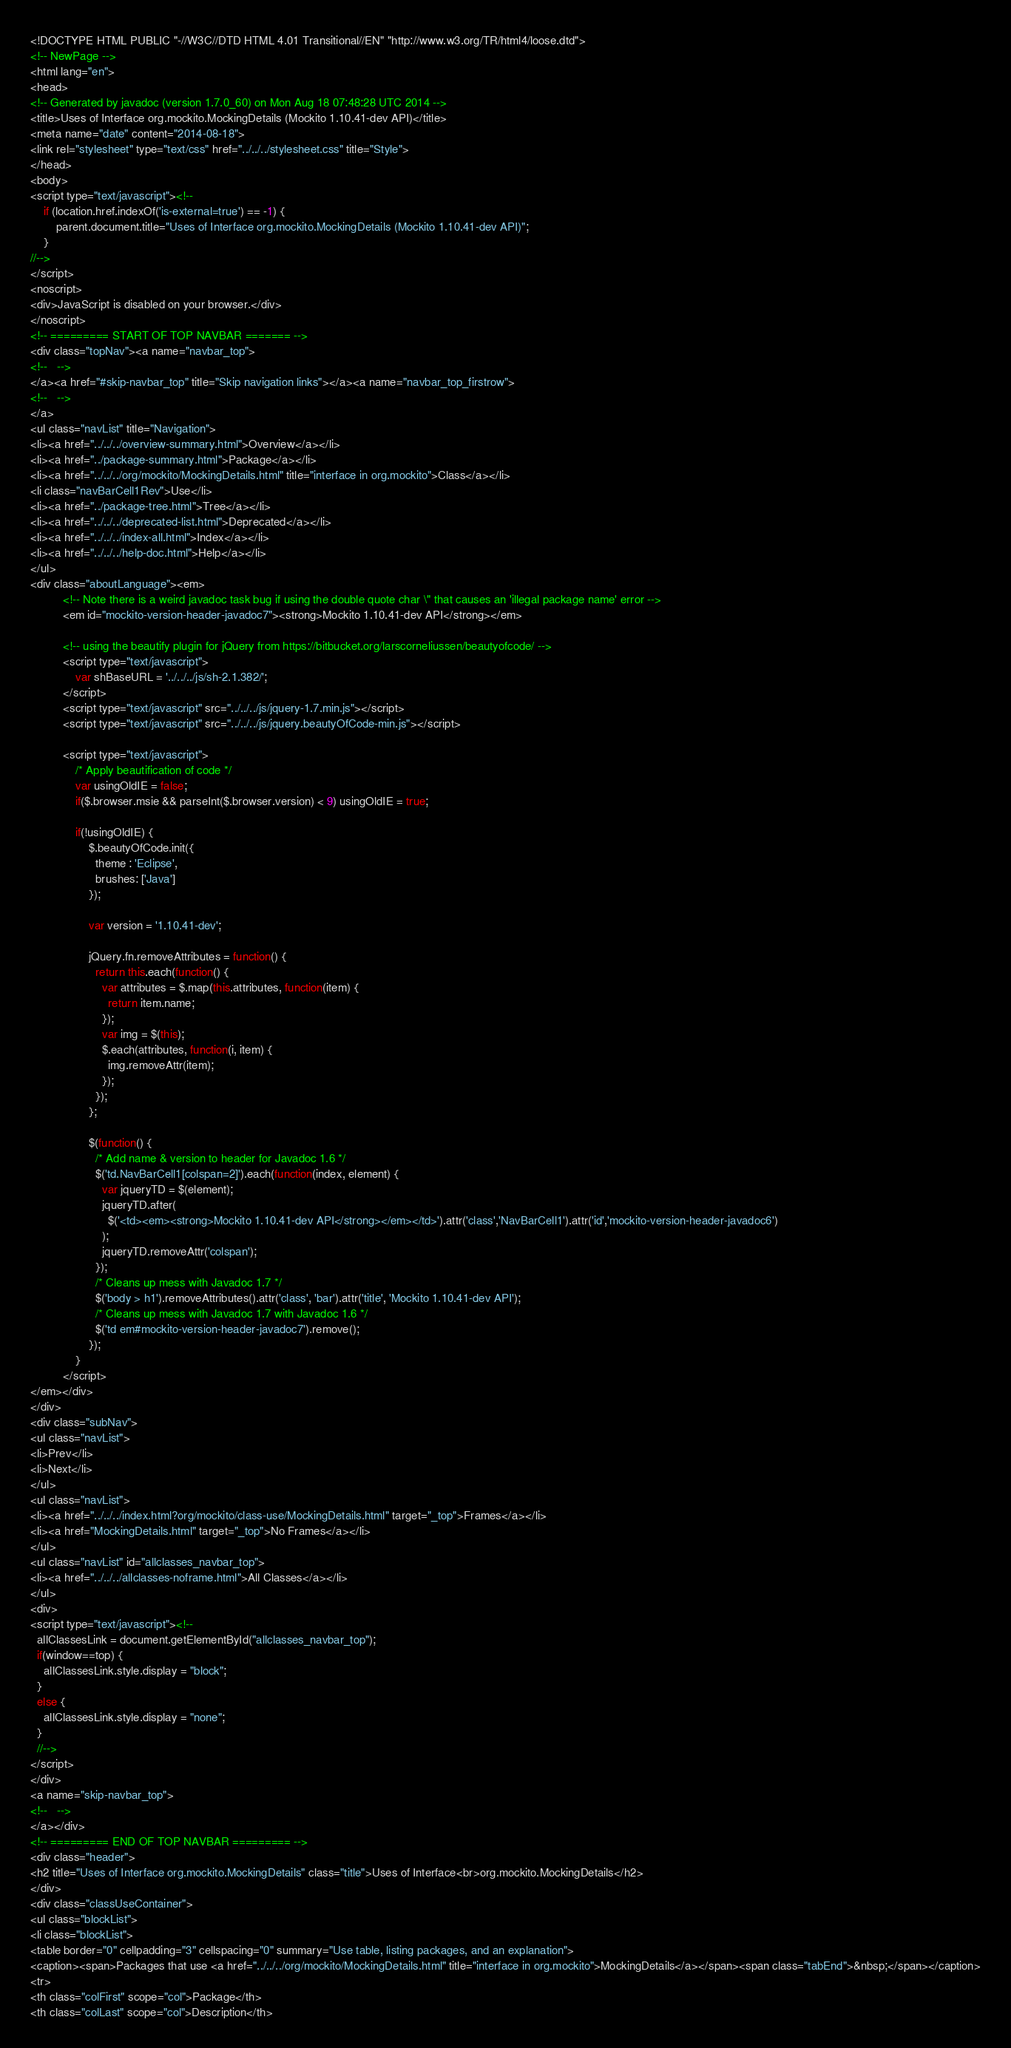Convert code to text. <code><loc_0><loc_0><loc_500><loc_500><_HTML_><!DOCTYPE HTML PUBLIC "-//W3C//DTD HTML 4.01 Transitional//EN" "http://www.w3.org/TR/html4/loose.dtd">
<!-- NewPage -->
<html lang="en">
<head>
<!-- Generated by javadoc (version 1.7.0_60) on Mon Aug 18 07:48:28 UTC 2014 -->
<title>Uses of Interface org.mockito.MockingDetails (Mockito 1.10.41-dev API)</title>
<meta name="date" content="2014-08-18">
<link rel="stylesheet" type="text/css" href="../../../stylesheet.css" title="Style">
</head>
<body>
<script type="text/javascript"><!--
    if (location.href.indexOf('is-external=true') == -1) {
        parent.document.title="Uses of Interface org.mockito.MockingDetails (Mockito 1.10.41-dev API)";
    }
//-->
</script>
<noscript>
<div>JavaScript is disabled on your browser.</div>
</noscript>
<!-- ========= START OF TOP NAVBAR ======= -->
<div class="topNav"><a name="navbar_top">
<!--   -->
</a><a href="#skip-navbar_top" title="Skip navigation links"></a><a name="navbar_top_firstrow">
<!--   -->
</a>
<ul class="navList" title="Navigation">
<li><a href="../../../overview-summary.html">Overview</a></li>
<li><a href="../package-summary.html">Package</a></li>
<li><a href="../../../org/mockito/MockingDetails.html" title="interface in org.mockito">Class</a></li>
<li class="navBarCell1Rev">Use</li>
<li><a href="../package-tree.html">Tree</a></li>
<li><a href="../../../deprecated-list.html">Deprecated</a></li>
<li><a href="../../../index-all.html">Index</a></li>
<li><a href="../../../help-doc.html">Help</a></li>
</ul>
<div class="aboutLanguage"><em>
          <!-- Note there is a weird javadoc task bug if using the double quote char \" that causes an 'illegal package name' error -->
          <em id="mockito-version-header-javadoc7"><strong>Mockito 1.10.41-dev API</strong></em>

          <!-- using the beautify plugin for jQuery from https://bitbucket.org/larscorneliussen/beautyofcode/ -->
          <script type="text/javascript">
              var shBaseURL = '../../../js/sh-2.1.382/';
          </script>
          <script type="text/javascript" src="../../../js/jquery-1.7.min.js"></script>
          <script type="text/javascript" src="../../../js/jquery.beautyOfCode-min.js"></script>

          <script type="text/javascript">
              /* Apply beautification of code */
              var usingOldIE = false;
              if($.browser.msie && parseInt($.browser.version) < 9) usingOldIE = true;

              if(!usingOldIE) {
                  $.beautyOfCode.init({
                    theme : 'Eclipse',
                    brushes: ['Java']
                  });

                  var version = '1.10.41-dev';

                  jQuery.fn.removeAttributes = function() {
                    return this.each(function() {
                      var attributes = $.map(this.attributes, function(item) {
                        return item.name;
                      });
                      var img = $(this);
                      $.each(attributes, function(i, item) {
                        img.removeAttr(item);
                      });
                    });
                  };

                  $(function() {
                    /* Add name & version to header for Javadoc 1.6 */
                    $('td.NavBarCell1[colspan=2]').each(function(index, element) {
                      var jqueryTD = $(element);
                      jqueryTD.after(
                        $('<td><em><strong>Mockito 1.10.41-dev API</strong></em></td>').attr('class','NavBarCell1').attr('id','mockito-version-header-javadoc6')
                      );
                      jqueryTD.removeAttr('colspan');
                    });
                    /* Cleans up mess with Javadoc 1.7 */
                    $('body > h1').removeAttributes().attr('class', 'bar').attr('title', 'Mockito 1.10.41-dev API');
                    /* Cleans up mess with Javadoc 1.7 with Javadoc 1.6 */
                    $('td em#mockito-version-header-javadoc7').remove();
                  });
              }
          </script>
</em></div>
</div>
<div class="subNav">
<ul class="navList">
<li>Prev</li>
<li>Next</li>
</ul>
<ul class="navList">
<li><a href="../../../index.html?org/mockito/class-use/MockingDetails.html" target="_top">Frames</a></li>
<li><a href="MockingDetails.html" target="_top">No Frames</a></li>
</ul>
<ul class="navList" id="allclasses_navbar_top">
<li><a href="../../../allclasses-noframe.html">All Classes</a></li>
</ul>
<div>
<script type="text/javascript"><!--
  allClassesLink = document.getElementById("allclasses_navbar_top");
  if(window==top) {
    allClassesLink.style.display = "block";
  }
  else {
    allClassesLink.style.display = "none";
  }
  //-->
</script>
</div>
<a name="skip-navbar_top">
<!--   -->
</a></div>
<!-- ========= END OF TOP NAVBAR ========= -->
<div class="header">
<h2 title="Uses of Interface org.mockito.MockingDetails" class="title">Uses of Interface<br>org.mockito.MockingDetails</h2>
</div>
<div class="classUseContainer">
<ul class="blockList">
<li class="blockList">
<table border="0" cellpadding="3" cellspacing="0" summary="Use table, listing packages, and an explanation">
<caption><span>Packages that use <a href="../../../org/mockito/MockingDetails.html" title="interface in org.mockito">MockingDetails</a></span><span class="tabEnd">&nbsp;</span></caption>
<tr>
<th class="colFirst" scope="col">Package</th>
<th class="colLast" scope="col">Description</th></code> 